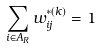<formula> <loc_0><loc_0><loc_500><loc_500>\sum _ { i \in A _ { R } } w _ { i j } ^ { * ( k ) } = 1</formula> 